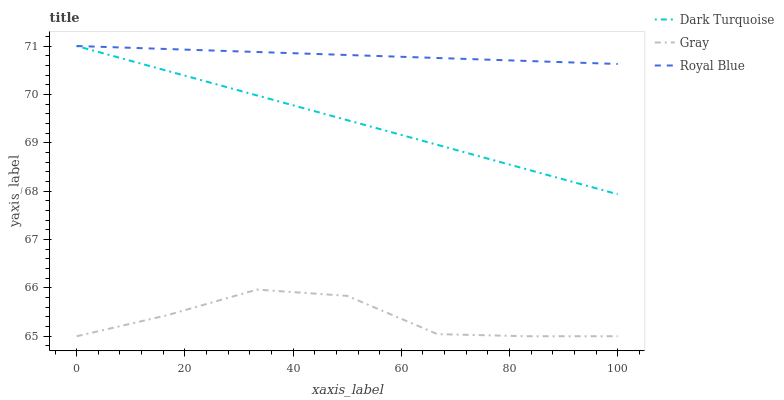Does Gray have the minimum area under the curve?
Answer yes or no. Yes. Does Royal Blue have the maximum area under the curve?
Answer yes or no. Yes. Does Royal Blue have the minimum area under the curve?
Answer yes or no. No. Does Gray have the maximum area under the curve?
Answer yes or no. No. Is Royal Blue the smoothest?
Answer yes or no. Yes. Is Gray the roughest?
Answer yes or no. Yes. Is Gray the smoothest?
Answer yes or no. No. Is Royal Blue the roughest?
Answer yes or no. No. Does Royal Blue have the lowest value?
Answer yes or no. No. Does Royal Blue have the highest value?
Answer yes or no. Yes. Does Gray have the highest value?
Answer yes or no. No. Is Gray less than Royal Blue?
Answer yes or no. Yes. Is Royal Blue greater than Gray?
Answer yes or no. Yes. Does Royal Blue intersect Dark Turquoise?
Answer yes or no. Yes. Is Royal Blue less than Dark Turquoise?
Answer yes or no. No. Is Royal Blue greater than Dark Turquoise?
Answer yes or no. No. Does Gray intersect Royal Blue?
Answer yes or no. No. 